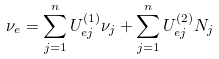Convert formula to latex. <formula><loc_0><loc_0><loc_500><loc_500>\nu _ { e } = \sum _ { j = 1 } ^ { n } U ^ { ( 1 ) } _ { e j } \nu _ { j } + \sum _ { j = 1 } ^ { n } U ^ { ( 2 ) } _ { e j } N _ { j }</formula> 